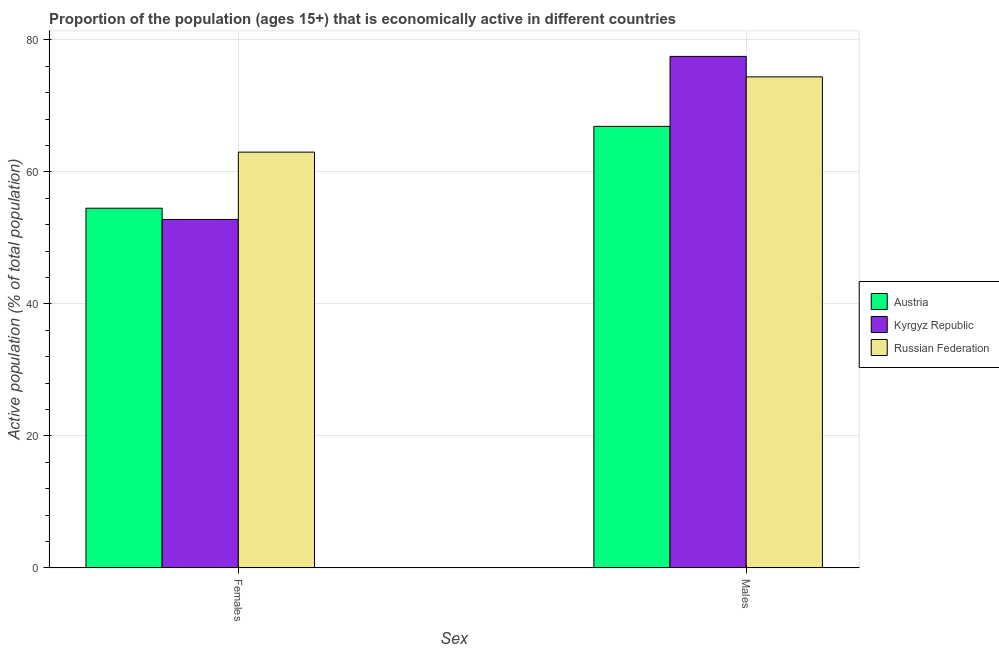Are the number of bars per tick equal to the number of legend labels?
Keep it short and to the point. Yes. Are the number of bars on each tick of the X-axis equal?
Offer a very short reply. Yes. How many bars are there on the 2nd tick from the left?
Make the answer very short. 3. How many bars are there on the 2nd tick from the right?
Ensure brevity in your answer.  3. What is the label of the 2nd group of bars from the left?
Ensure brevity in your answer.  Males. What is the percentage of economically active male population in Russian Federation?
Your response must be concise. 74.4. Across all countries, what is the minimum percentage of economically active female population?
Make the answer very short. 52.8. In which country was the percentage of economically active female population maximum?
Your answer should be compact. Russian Federation. In which country was the percentage of economically active female population minimum?
Keep it short and to the point. Kyrgyz Republic. What is the total percentage of economically active male population in the graph?
Your answer should be compact. 218.8. What is the difference between the percentage of economically active male population in Austria and that in Russian Federation?
Offer a very short reply. -7.5. What is the difference between the percentage of economically active male population in Russian Federation and the percentage of economically active female population in Austria?
Offer a terse response. 19.9. What is the average percentage of economically active female population per country?
Your response must be concise. 56.77. What is the difference between the percentage of economically active male population and percentage of economically active female population in Russian Federation?
Your answer should be compact. 11.4. In how many countries, is the percentage of economically active male population greater than 8 %?
Your answer should be very brief. 3. What is the ratio of the percentage of economically active male population in Russian Federation to that in Kyrgyz Republic?
Your response must be concise. 0.96. In how many countries, is the percentage of economically active male population greater than the average percentage of economically active male population taken over all countries?
Give a very brief answer. 2. What does the 2nd bar from the left in Males represents?
Ensure brevity in your answer.  Kyrgyz Republic. What does the 2nd bar from the right in Females represents?
Your answer should be compact. Kyrgyz Republic. Are all the bars in the graph horizontal?
Your answer should be very brief. No. What is the difference between two consecutive major ticks on the Y-axis?
Your answer should be compact. 20. Where does the legend appear in the graph?
Provide a succinct answer. Center right. How many legend labels are there?
Ensure brevity in your answer.  3. How are the legend labels stacked?
Your answer should be very brief. Vertical. What is the title of the graph?
Ensure brevity in your answer.  Proportion of the population (ages 15+) that is economically active in different countries. What is the label or title of the X-axis?
Offer a very short reply. Sex. What is the label or title of the Y-axis?
Your response must be concise. Active population (% of total population). What is the Active population (% of total population) of Austria in Females?
Provide a short and direct response. 54.5. What is the Active population (% of total population) in Kyrgyz Republic in Females?
Give a very brief answer. 52.8. What is the Active population (% of total population) of Austria in Males?
Provide a short and direct response. 66.9. What is the Active population (% of total population) of Kyrgyz Republic in Males?
Keep it short and to the point. 77.5. What is the Active population (% of total population) of Russian Federation in Males?
Offer a very short reply. 74.4. Across all Sex, what is the maximum Active population (% of total population) in Austria?
Keep it short and to the point. 66.9. Across all Sex, what is the maximum Active population (% of total population) in Kyrgyz Republic?
Offer a terse response. 77.5. Across all Sex, what is the maximum Active population (% of total population) in Russian Federation?
Make the answer very short. 74.4. Across all Sex, what is the minimum Active population (% of total population) in Austria?
Provide a short and direct response. 54.5. Across all Sex, what is the minimum Active population (% of total population) in Kyrgyz Republic?
Your answer should be compact. 52.8. Across all Sex, what is the minimum Active population (% of total population) of Russian Federation?
Give a very brief answer. 63. What is the total Active population (% of total population) of Austria in the graph?
Make the answer very short. 121.4. What is the total Active population (% of total population) in Kyrgyz Republic in the graph?
Your answer should be compact. 130.3. What is the total Active population (% of total population) of Russian Federation in the graph?
Offer a very short reply. 137.4. What is the difference between the Active population (% of total population) of Austria in Females and that in Males?
Your response must be concise. -12.4. What is the difference between the Active population (% of total population) in Kyrgyz Republic in Females and that in Males?
Provide a short and direct response. -24.7. What is the difference between the Active population (% of total population) in Austria in Females and the Active population (% of total population) in Russian Federation in Males?
Your response must be concise. -19.9. What is the difference between the Active population (% of total population) of Kyrgyz Republic in Females and the Active population (% of total population) of Russian Federation in Males?
Offer a terse response. -21.6. What is the average Active population (% of total population) in Austria per Sex?
Ensure brevity in your answer.  60.7. What is the average Active population (% of total population) in Kyrgyz Republic per Sex?
Make the answer very short. 65.15. What is the average Active population (% of total population) of Russian Federation per Sex?
Make the answer very short. 68.7. What is the difference between the Active population (% of total population) in Austria and Active population (% of total population) in Kyrgyz Republic in Females?
Make the answer very short. 1.7. What is the difference between the Active population (% of total population) of Austria and Active population (% of total population) of Russian Federation in Males?
Offer a terse response. -7.5. What is the ratio of the Active population (% of total population) of Austria in Females to that in Males?
Provide a succinct answer. 0.81. What is the ratio of the Active population (% of total population) in Kyrgyz Republic in Females to that in Males?
Offer a terse response. 0.68. What is the ratio of the Active population (% of total population) in Russian Federation in Females to that in Males?
Offer a terse response. 0.85. What is the difference between the highest and the second highest Active population (% of total population) in Kyrgyz Republic?
Provide a short and direct response. 24.7. What is the difference between the highest and the lowest Active population (% of total population) in Austria?
Keep it short and to the point. 12.4. What is the difference between the highest and the lowest Active population (% of total population) of Kyrgyz Republic?
Offer a very short reply. 24.7. What is the difference between the highest and the lowest Active population (% of total population) in Russian Federation?
Provide a short and direct response. 11.4. 